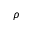<formula> <loc_0><loc_0><loc_500><loc_500>\rho</formula> 